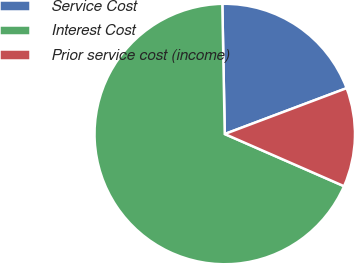<chart> <loc_0><loc_0><loc_500><loc_500><pie_chart><fcel>Service Cost<fcel>Interest Cost<fcel>Prior service cost (income)<nl><fcel>19.57%<fcel>68.14%<fcel>12.29%<nl></chart> 